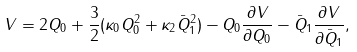Convert formula to latex. <formula><loc_0><loc_0><loc_500><loc_500>V = 2 Q _ { 0 } + \frac { 3 } { 2 } ( \kappa _ { 0 } Q _ { 0 } ^ { 2 } + \kappa _ { 2 } \bar { Q } _ { 1 } ^ { 2 } ) - Q _ { 0 } \frac { \partial V } { \partial Q _ { 0 } } - \bar { Q } _ { 1 } \frac { \partial V } { \partial \bar { Q } _ { 1 } } ,</formula> 